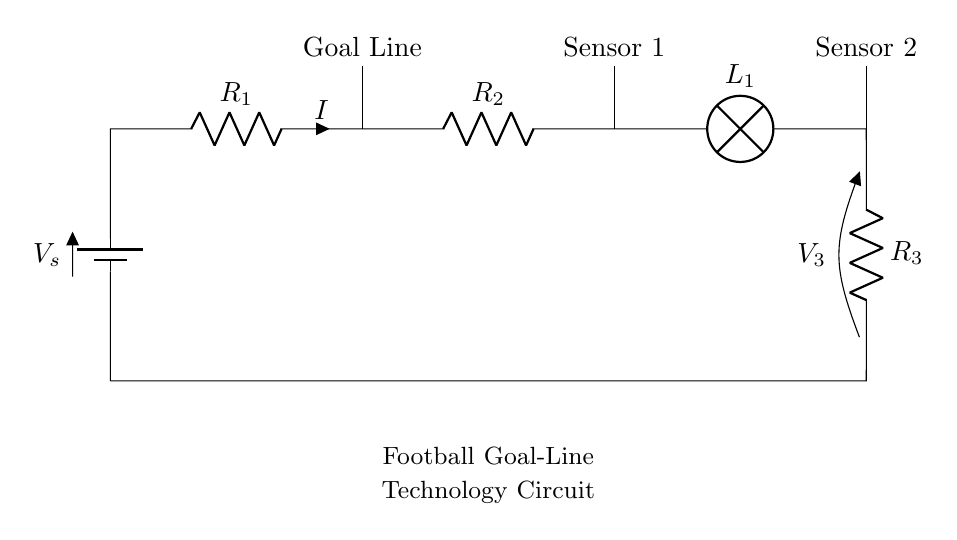What is the total resistance of the circuit? The total resistance in a series circuit is the sum of all resistances. Here, R1, R2, and R3 are in series, so the total resistance \( R_{total} = R_1 + R_2 + R_3 \).
Answer: R1 + R2 + R3 How many sensors are in the circuit? The diagram shows two sensors labeled as Sensor 1 and Sensor 2, which indicates that there are two sensors present in the circuit.
Answer: 2 What is the role of the lamp in this circuit? The lamp, labeled L1, is typically used to indicate whether current is flowing through the circuit. If it lights up, it shows that the circuit is complete and functioning.
Answer: Indicator What is the direction of current flow in this circuit? In a series circuit, current flows from the positive terminal of the battery, through the resistors, and then through the lamp before returning to the battery. This establishes a clear direction from the battery to the load.
Answer: From battery to load If the voltage source is 12V and the total resistance is 6 ohms, what is the current flowing through the circuit? According to Ohm’s Law, current \( I \) can be calculated using the formula \( I = V / R \). In this case, with a voltage of 12 volts and a total resistance of 6 ohms, \( I = 12V / 6Ω = 2A \). So the current flowing is 2 Amperes.
Answer: 2A What happens if one of the resistors in this circuit fails? In a series circuit, if one component (like a resistor) fails, it interrupts the entire circuit, resulting in no current flow. This means that the lamp would not light up, as the circuit is incomplete.
Answer: Circuit fails 